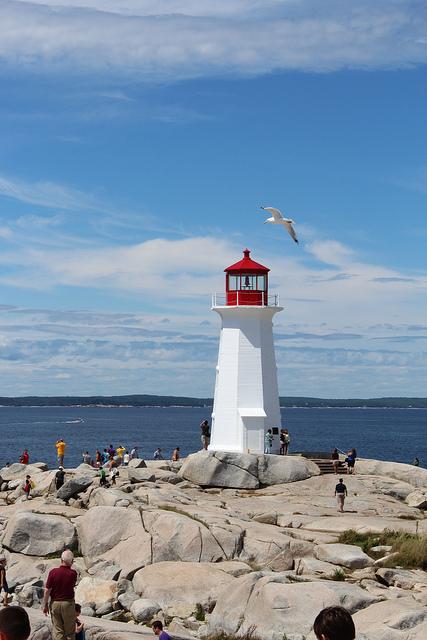What color is the top of the lighthouse?
Answer briefly. Red. What is this building?
Answer briefly. Lighthouse. How many birds are in the sky?
Concise answer only. 1. 